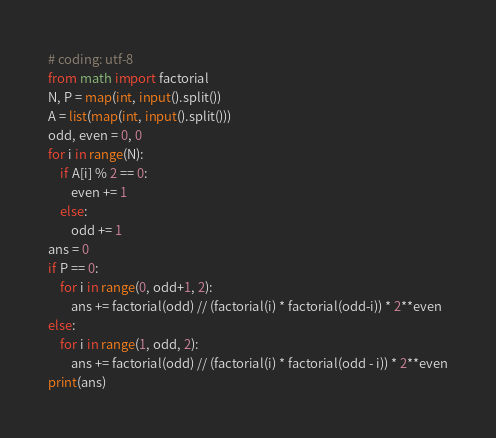Convert code to text. <code><loc_0><loc_0><loc_500><loc_500><_Python_># coding: utf-8
from math import factorial
N, P = map(int, input().split())
A = list(map(int, input().split()))
odd, even = 0, 0
for i in range(N):
    if A[i] % 2 == 0:
        even += 1
    else:
        odd += 1
ans = 0
if P == 0:
    for i in range(0, odd+1, 2):
        ans += factorial(odd) // (factorial(i) * factorial(odd-i)) * 2**even
else:
    for i in range(1, odd, 2):
        ans += factorial(odd) // (factorial(i) * factorial(odd - i)) * 2**even
print(ans)</code> 